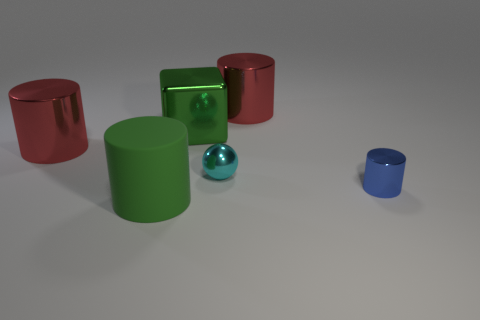Subtract all gray cylinders. Subtract all yellow balls. How many cylinders are left? 4 Add 2 large green blocks. How many objects exist? 8 Subtract all blocks. How many objects are left? 5 Add 1 green rubber objects. How many green rubber objects exist? 2 Subtract 0 purple blocks. How many objects are left? 6 Subtract all brown shiny blocks. Subtract all small cylinders. How many objects are left? 5 Add 4 blue objects. How many blue objects are left? 5 